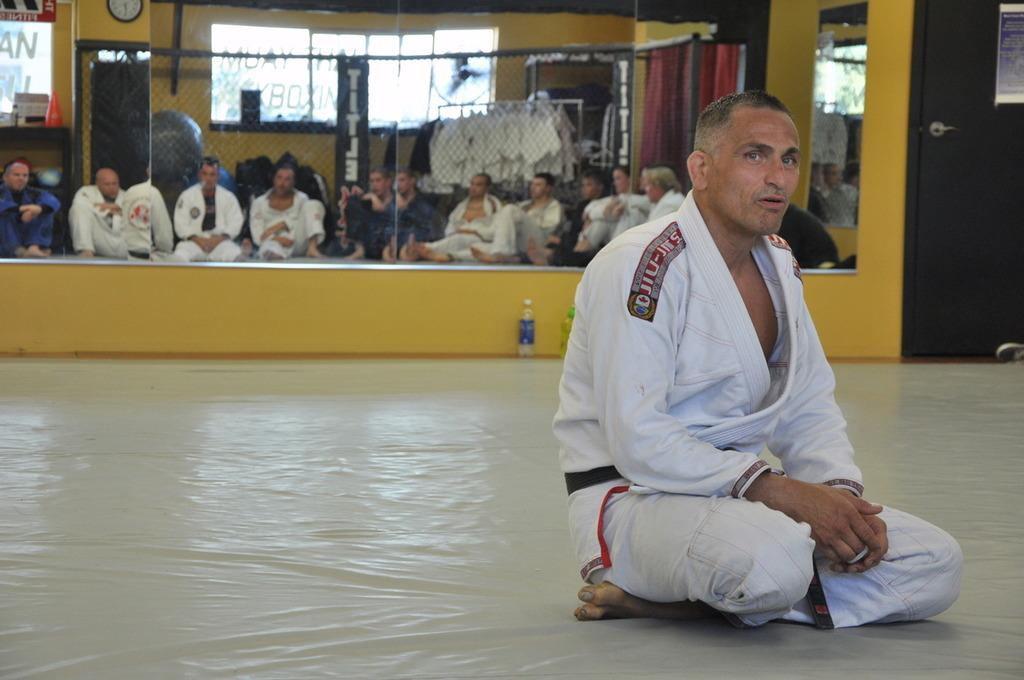<image>
Create a compact narrative representing the image presented. A martial arts instructor sitting in front of the class, with Japanese writing on his shoulders. 